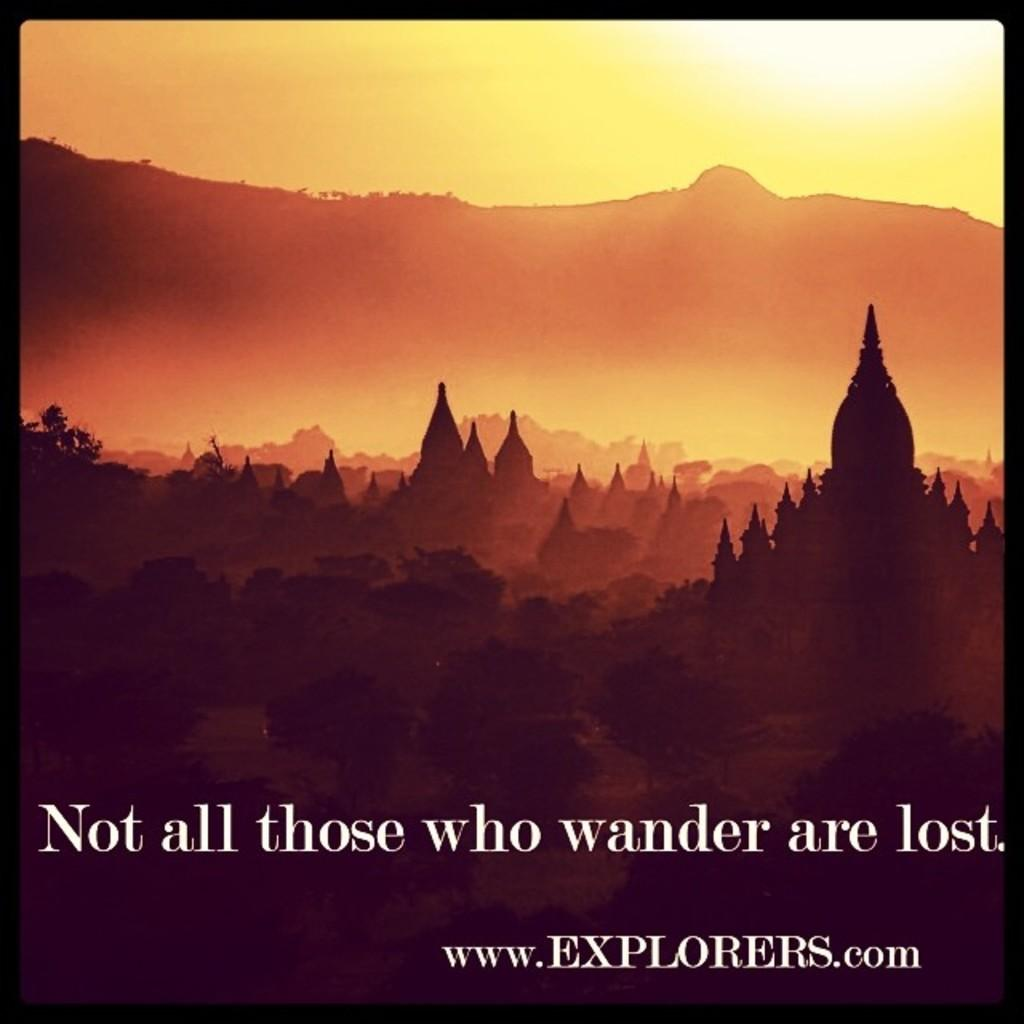<image>
Create a compact narrative representing the image presented. A poster of an ad for explorers.com that includeds a photo of the forest, a temple and a mountain scene. 